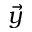Convert formula to latex. <formula><loc_0><loc_0><loc_500><loc_500>\vec { y }</formula> 